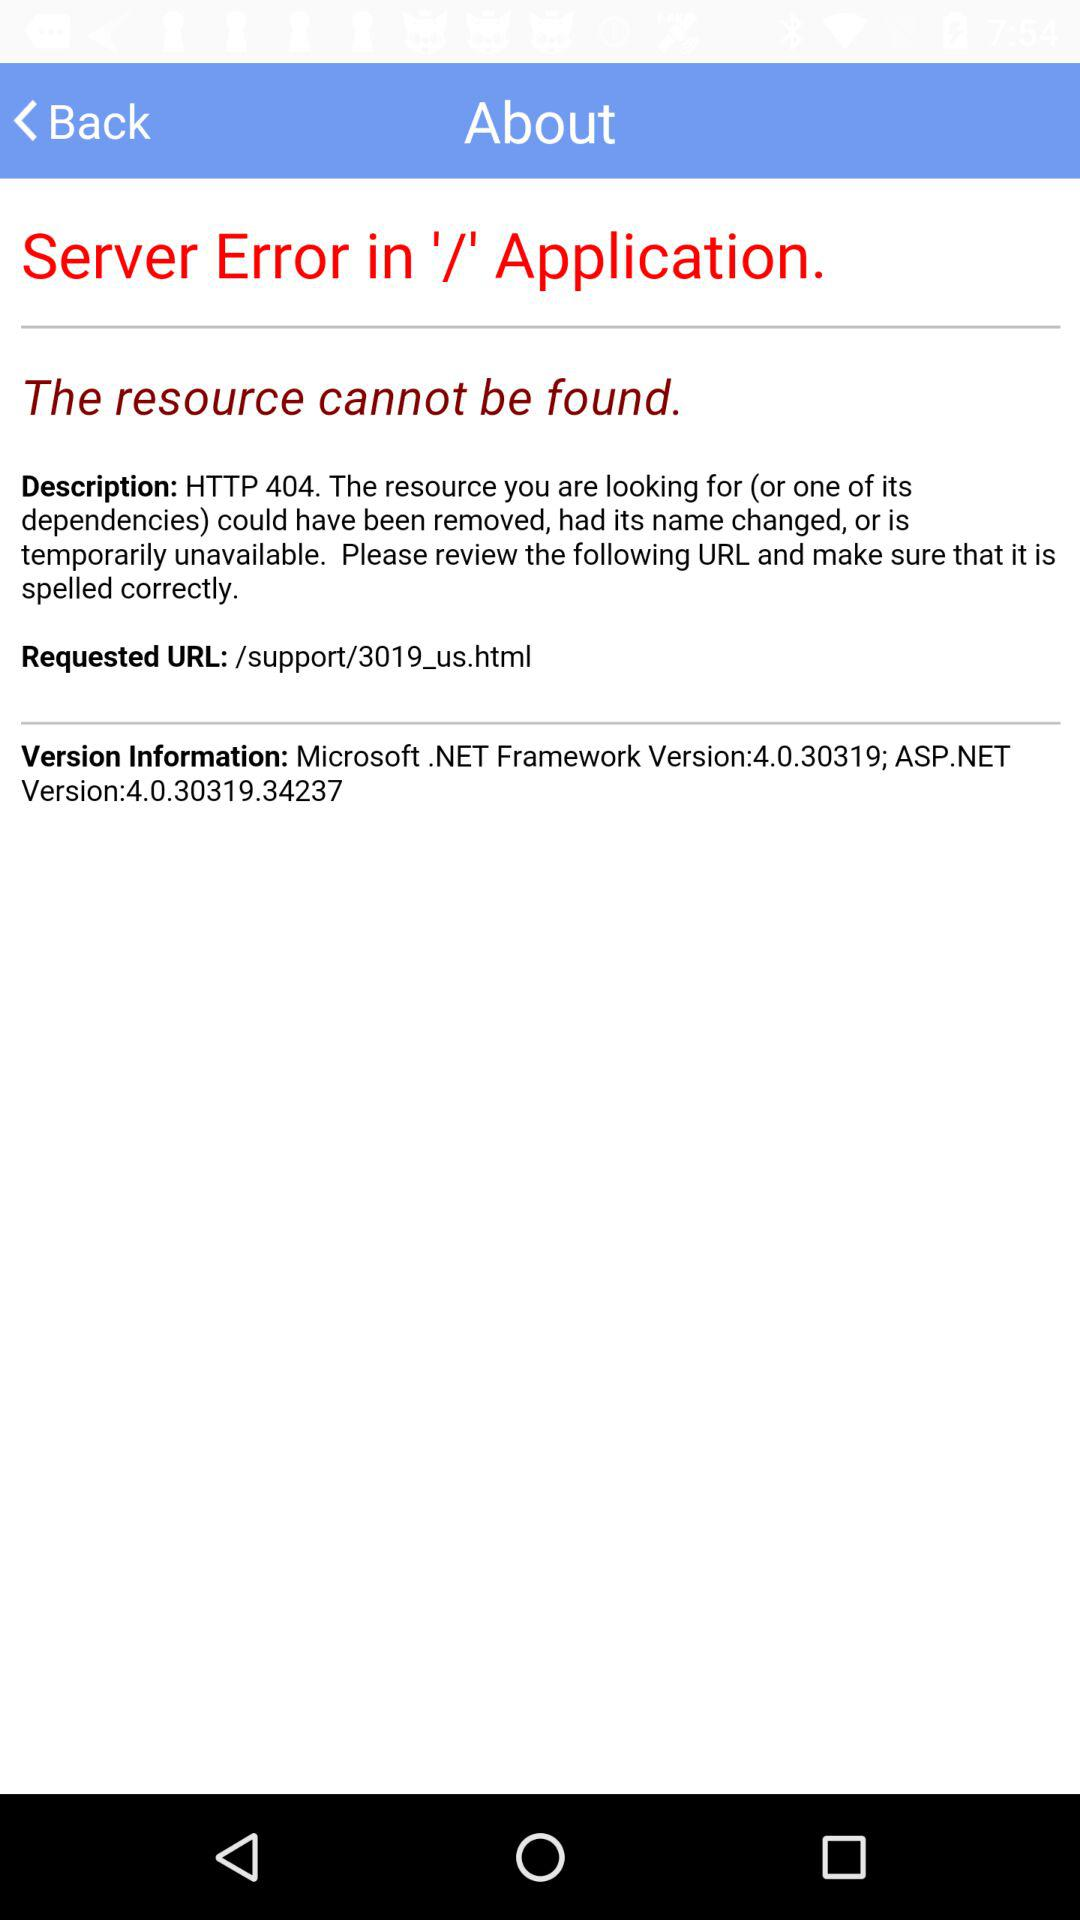What can't be found? The resource can't be found. 